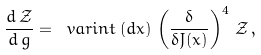<formula> <loc_0><loc_0><loc_500><loc_500>\frac { d \, \mathcal { Z } } { d \, g } = \ v a r i n t \, ( d x ) \, \left ( \frac { \delta } { \delta J ( x ) } \right ) ^ { 4 } \, \mathcal { Z } \, ,</formula> 